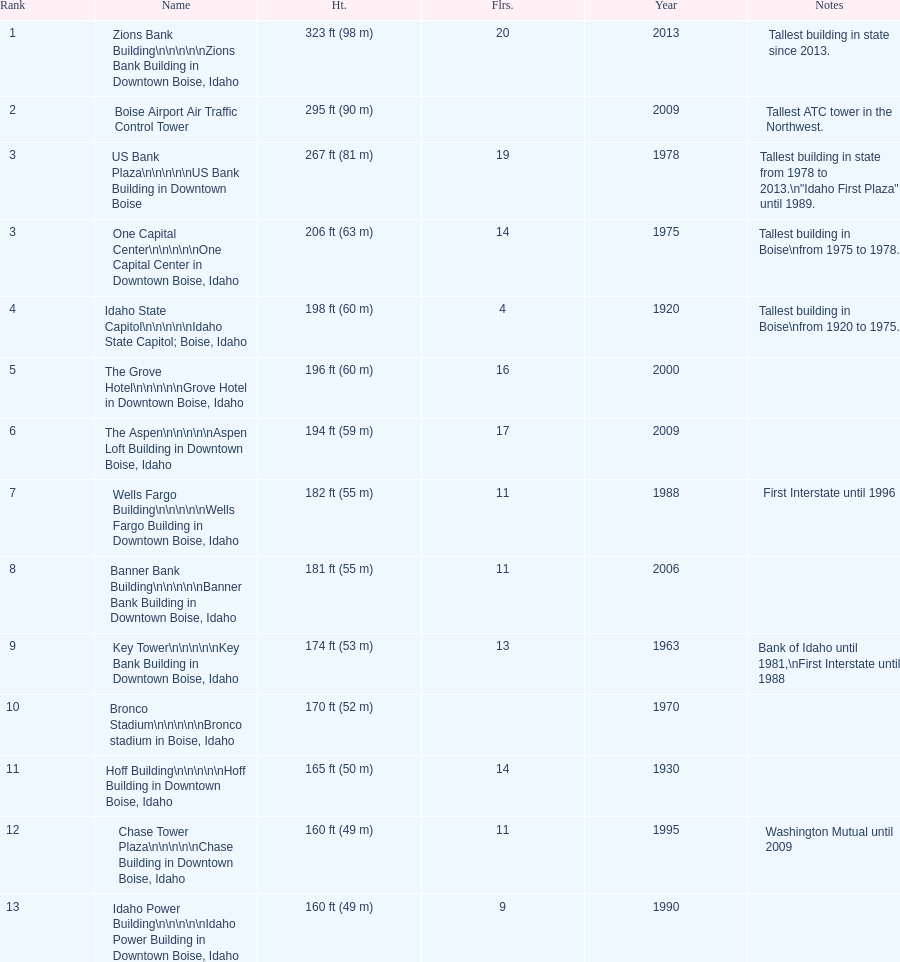What are the number of floors the us bank plaza has? 19. Would you be able to parse every entry in this table? {'header': ['Rank', 'Name', 'Ht.', 'Flrs.', 'Year', 'Notes'], 'rows': [['1', 'Zions Bank Building\\n\\n\\n\\n\\nZions Bank Building in Downtown Boise, Idaho', '323\xa0ft (98\xa0m)', '20', '2013', 'Tallest building in state since 2013.'], ['2', 'Boise Airport Air Traffic Control Tower', '295\xa0ft (90\xa0m)', '', '2009', 'Tallest ATC tower in the Northwest.'], ['3', 'US Bank Plaza\\n\\n\\n\\n\\nUS Bank Building in Downtown Boise', '267\xa0ft (81\xa0m)', '19', '1978', 'Tallest building in state from 1978 to 2013.\\n"Idaho First Plaza" until 1989.'], ['3', 'One Capital Center\\n\\n\\n\\n\\nOne Capital Center in Downtown Boise, Idaho', '206\xa0ft (63\xa0m)', '14', '1975', 'Tallest building in Boise\\nfrom 1975 to 1978.'], ['4', 'Idaho State Capitol\\n\\n\\n\\n\\nIdaho State Capitol; Boise, Idaho', '198\xa0ft (60\xa0m)', '4', '1920', 'Tallest building in Boise\\nfrom 1920 to 1975.'], ['5', 'The Grove Hotel\\n\\n\\n\\n\\nGrove Hotel in Downtown Boise, Idaho', '196\xa0ft (60\xa0m)', '16', '2000', ''], ['6', 'The Aspen\\n\\n\\n\\n\\nAspen Loft Building in Downtown Boise, Idaho', '194\xa0ft (59\xa0m)', '17', '2009', ''], ['7', 'Wells Fargo Building\\n\\n\\n\\n\\nWells Fargo Building in Downtown Boise, Idaho', '182\xa0ft (55\xa0m)', '11', '1988', 'First Interstate until 1996'], ['8', 'Banner Bank Building\\n\\n\\n\\n\\nBanner Bank Building in Downtown Boise, Idaho', '181\xa0ft (55\xa0m)', '11', '2006', ''], ['9', 'Key Tower\\n\\n\\n\\n\\nKey Bank Building in Downtown Boise, Idaho', '174\xa0ft (53\xa0m)', '13', '1963', 'Bank of Idaho until 1981,\\nFirst Interstate until 1988'], ['10', 'Bronco Stadium\\n\\n\\n\\n\\nBronco stadium in Boise, Idaho', '170\xa0ft (52\xa0m)', '', '1970', ''], ['11', 'Hoff Building\\n\\n\\n\\n\\nHoff Building in Downtown Boise, Idaho', '165\xa0ft (50\xa0m)', '14', '1930', ''], ['12', 'Chase Tower Plaza\\n\\n\\n\\n\\nChase Building in Downtown Boise, Idaho', '160\xa0ft (49\xa0m)', '11', '1995', 'Washington Mutual until 2009'], ['13', 'Idaho Power Building\\n\\n\\n\\n\\nIdaho Power Building in Downtown Boise, Idaho', '160\xa0ft (49\xa0m)', '9', '1990', '']]} 